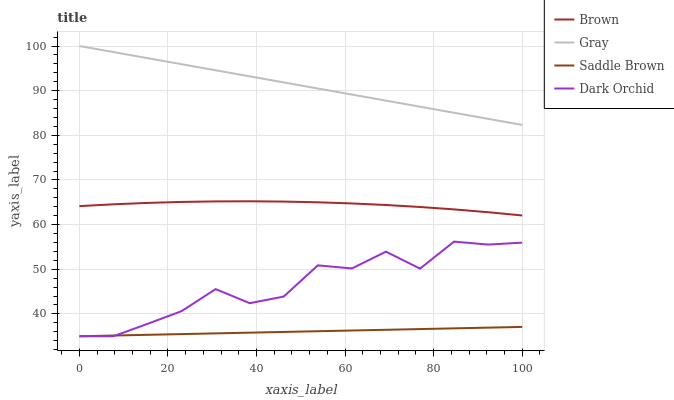Does Saddle Brown have the minimum area under the curve?
Answer yes or no. Yes. Does Gray have the maximum area under the curve?
Answer yes or no. Yes. Does Dark Orchid have the minimum area under the curve?
Answer yes or no. No. Does Dark Orchid have the maximum area under the curve?
Answer yes or no. No. Is Saddle Brown the smoothest?
Answer yes or no. Yes. Is Dark Orchid the roughest?
Answer yes or no. Yes. Is Dark Orchid the smoothest?
Answer yes or no. No. Is Saddle Brown the roughest?
Answer yes or no. No. Does Gray have the lowest value?
Answer yes or no. No. Does Gray have the highest value?
Answer yes or no. Yes. Does Dark Orchid have the highest value?
Answer yes or no. No. Is Brown less than Gray?
Answer yes or no. Yes. Is Brown greater than Saddle Brown?
Answer yes or no. Yes. Does Dark Orchid intersect Saddle Brown?
Answer yes or no. Yes. Is Dark Orchid less than Saddle Brown?
Answer yes or no. No. Is Dark Orchid greater than Saddle Brown?
Answer yes or no. No. Does Brown intersect Gray?
Answer yes or no. No. 